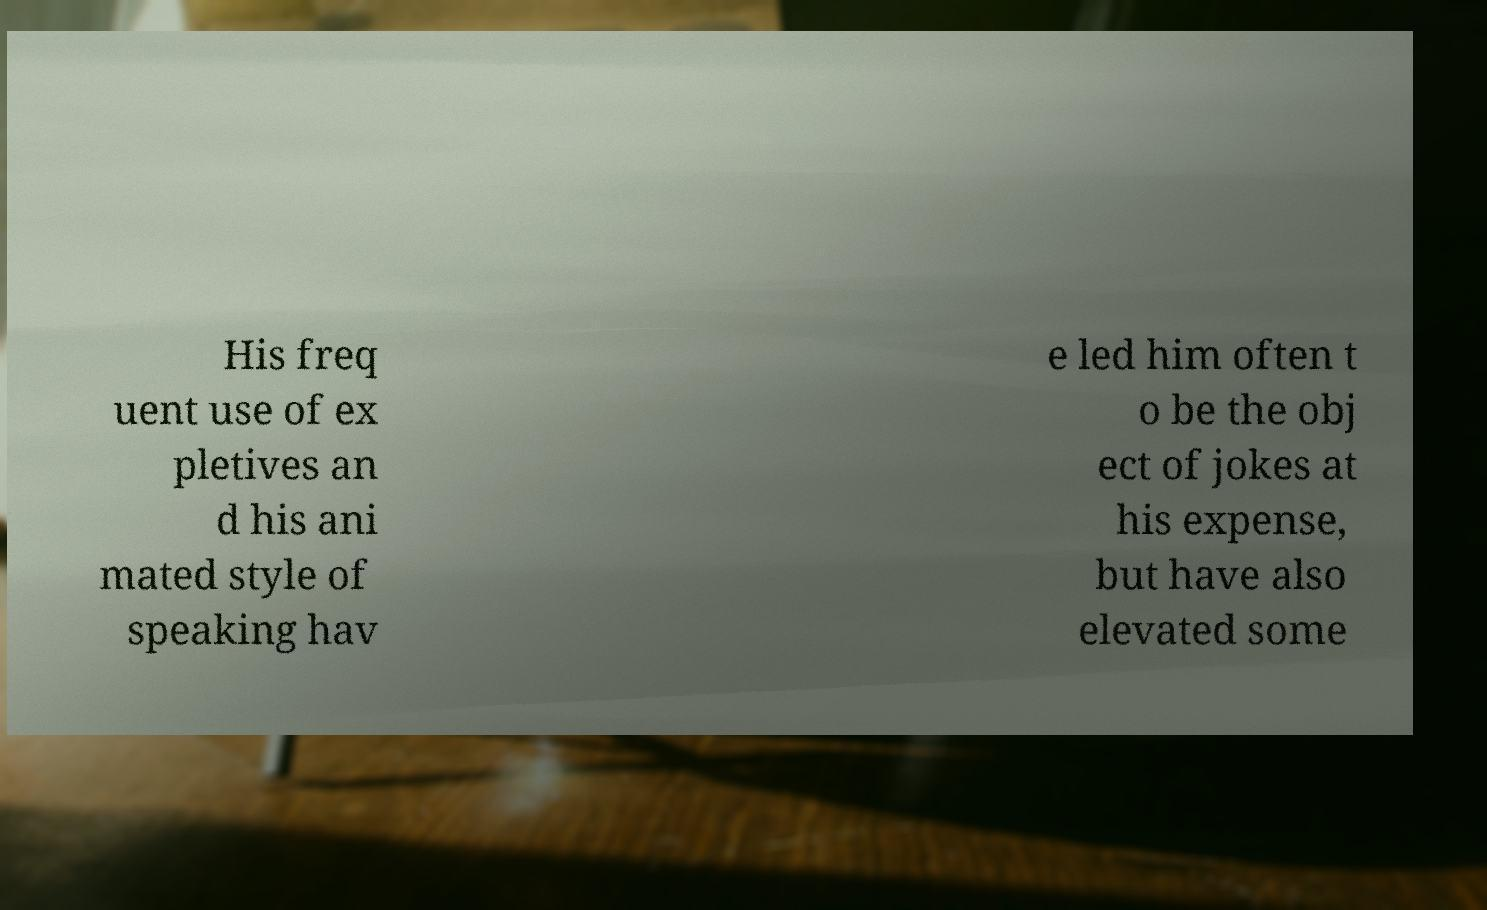Please identify and transcribe the text found in this image. His freq uent use of ex pletives an d his ani mated style of speaking hav e led him often t o be the obj ect of jokes at his expense, but have also elevated some 